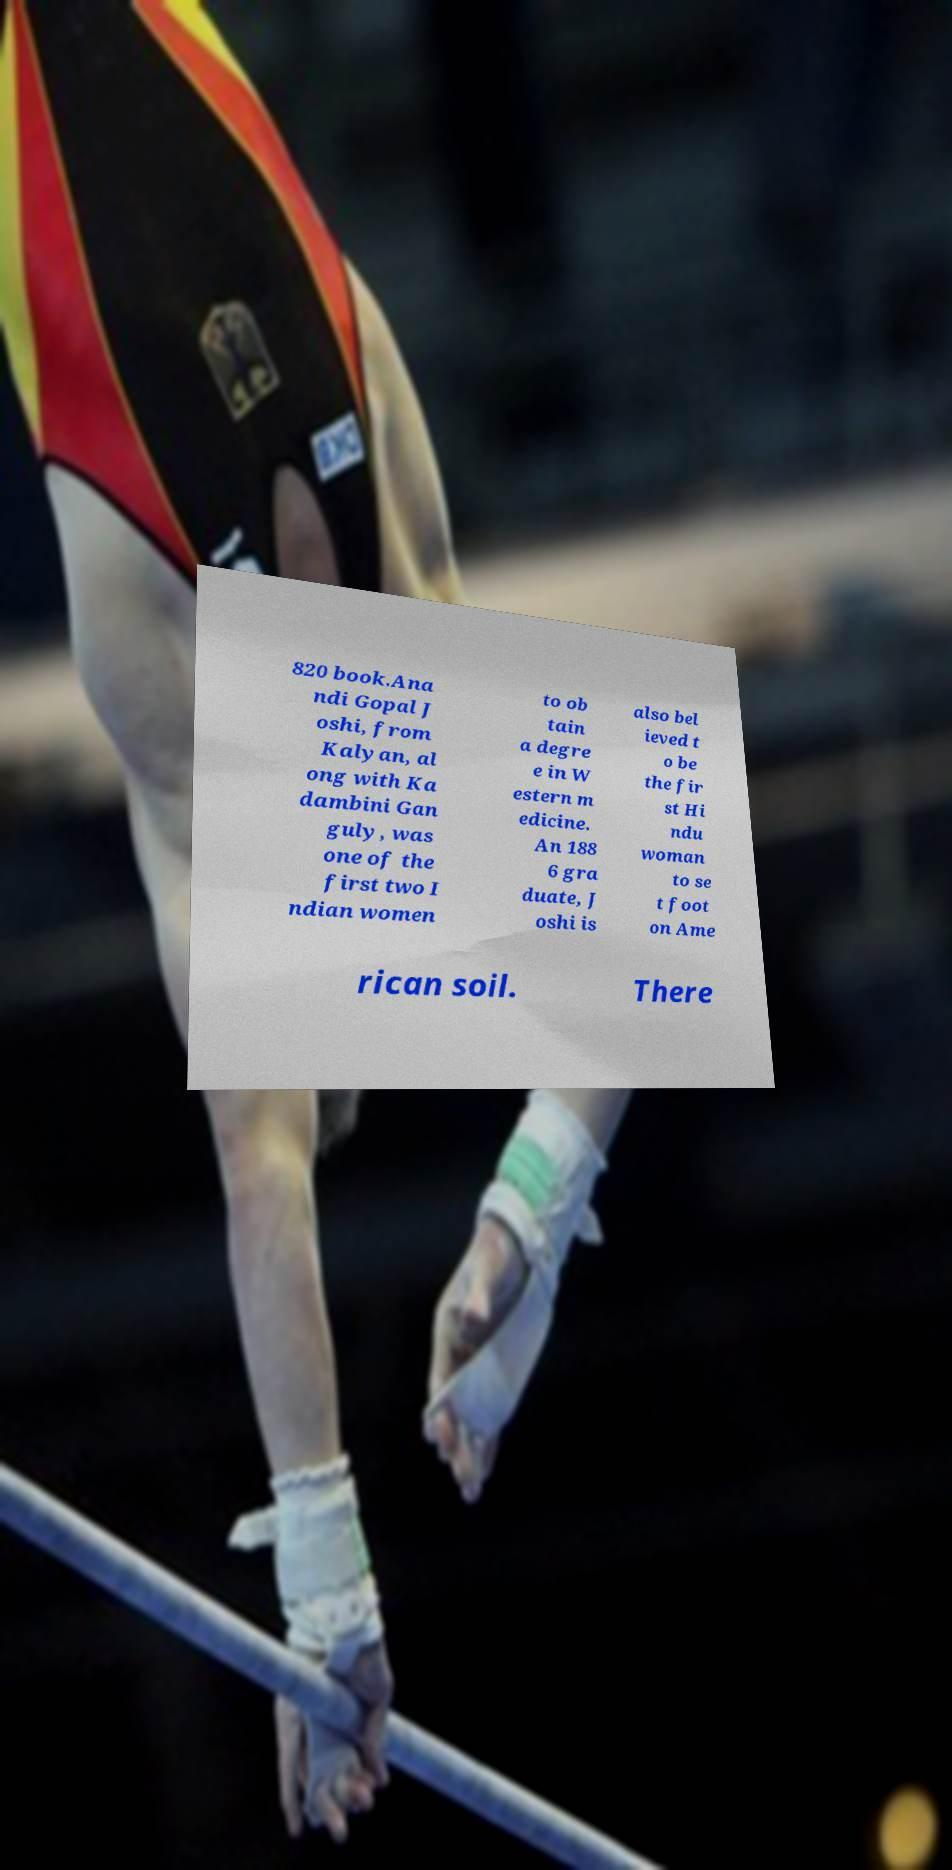I need the written content from this picture converted into text. Can you do that? 820 book.Ana ndi Gopal J oshi, from Kalyan, al ong with Ka dambini Gan guly, was one of the first two I ndian women to ob tain a degre e in W estern m edicine. An 188 6 gra duate, J oshi is also bel ieved t o be the fir st Hi ndu woman to se t foot on Ame rican soil. There 